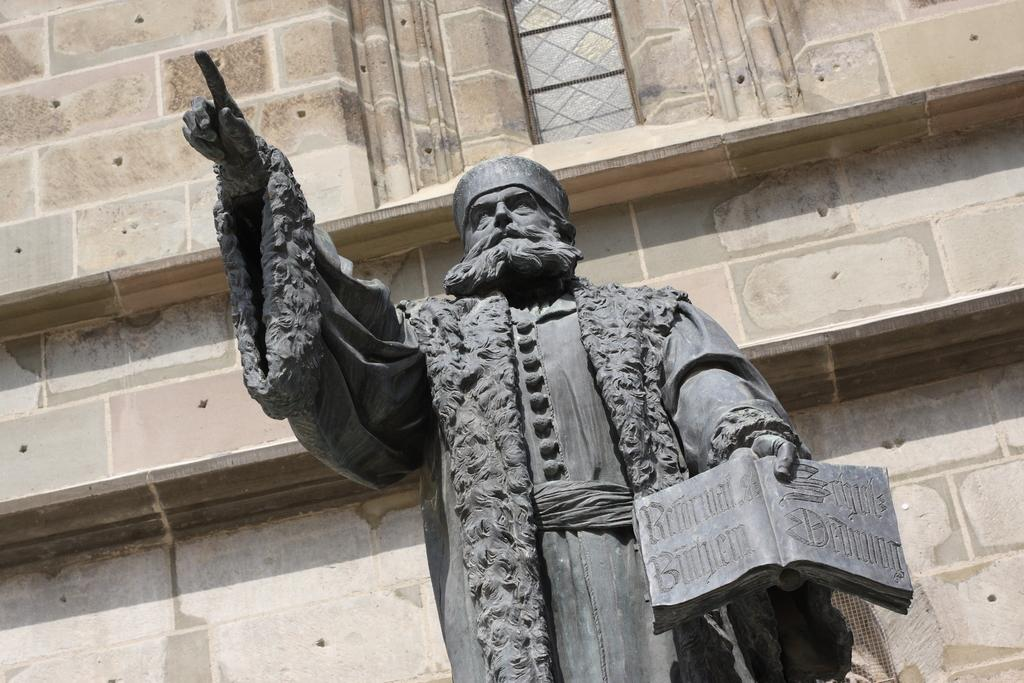What is the main subject in the center of the image? There is a statue in the center of the image. What is the color of the statue? The statue is black in color. What can be seen in the background of the image? There is a building, a wall, and a window in the background of the image. What type of tail can be seen on the statue in the image? There is no tail present on the statue in the image. What activity is the statue engaged in within the image? The statue is not engaged in any activity; it is a stationary object. 